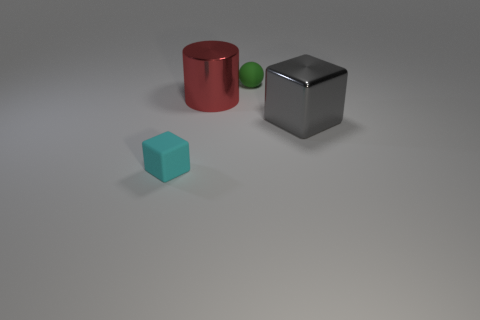Is there a big red cylinder that is on the right side of the small object that is in front of the block right of the green thing?
Give a very brief answer. Yes. How many things are large metallic things that are in front of the large cylinder or large metallic objects that are to the right of the tiny matte sphere?
Offer a very short reply. 1. Is the small thing on the left side of the red metallic object made of the same material as the large gray block?
Make the answer very short. No. There is a object that is both in front of the tiny green rubber object and behind the big gray metallic block; what material is it?
Your response must be concise. Metal. The large shiny thing that is to the left of the tiny rubber thing that is behind the big gray cube is what color?
Offer a very short reply. Red. There is a large gray thing that is the same shape as the cyan rubber thing; what is it made of?
Your answer should be compact. Metal. What color is the rubber object that is right of the big metallic object that is on the left side of the tiny thing right of the tiny cyan object?
Ensure brevity in your answer.  Green. How many things are shiny balls or small rubber objects?
Your answer should be very brief. 2. How many metal things have the same shape as the small cyan rubber object?
Provide a short and direct response. 1. Does the red cylinder have the same material as the cube that is behind the cyan thing?
Give a very brief answer. Yes. 